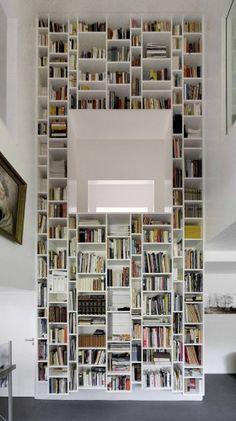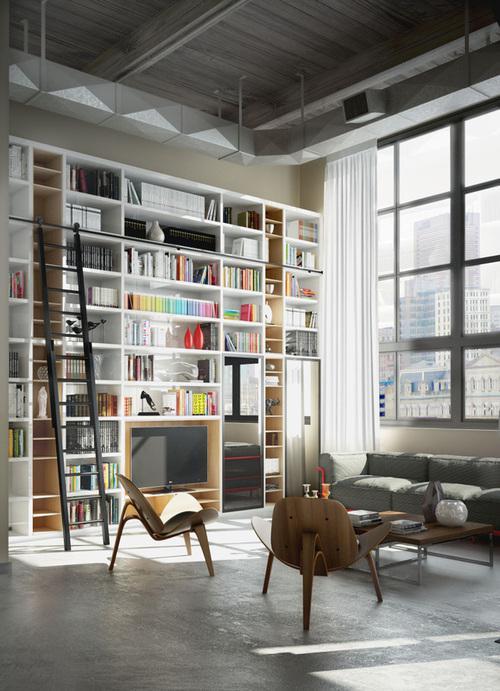The first image is the image on the left, the second image is the image on the right. Evaluate the accuracy of this statement regarding the images: "There is one ladder leaning against a bookcase.". Is it true? Answer yes or no. Yes. The first image is the image on the left, the second image is the image on the right. Evaluate the accuracy of this statement regarding the images: "The reading are in the image on the right includes seating near a window.". Is it true? Answer yes or no. Yes. 